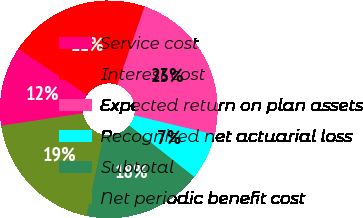<chart> <loc_0><loc_0><loc_500><loc_500><pie_chart><fcel>Service cost<fcel>Interest cost<fcel>Expected return on plan assets<fcel>Recognized net actuarial loss<fcel>Subtotal<fcel>Net periodic benefit cost<nl><fcel>11.81%<fcel>20.94%<fcel>23.41%<fcel>6.9%<fcel>17.64%<fcel>19.29%<nl></chart> 